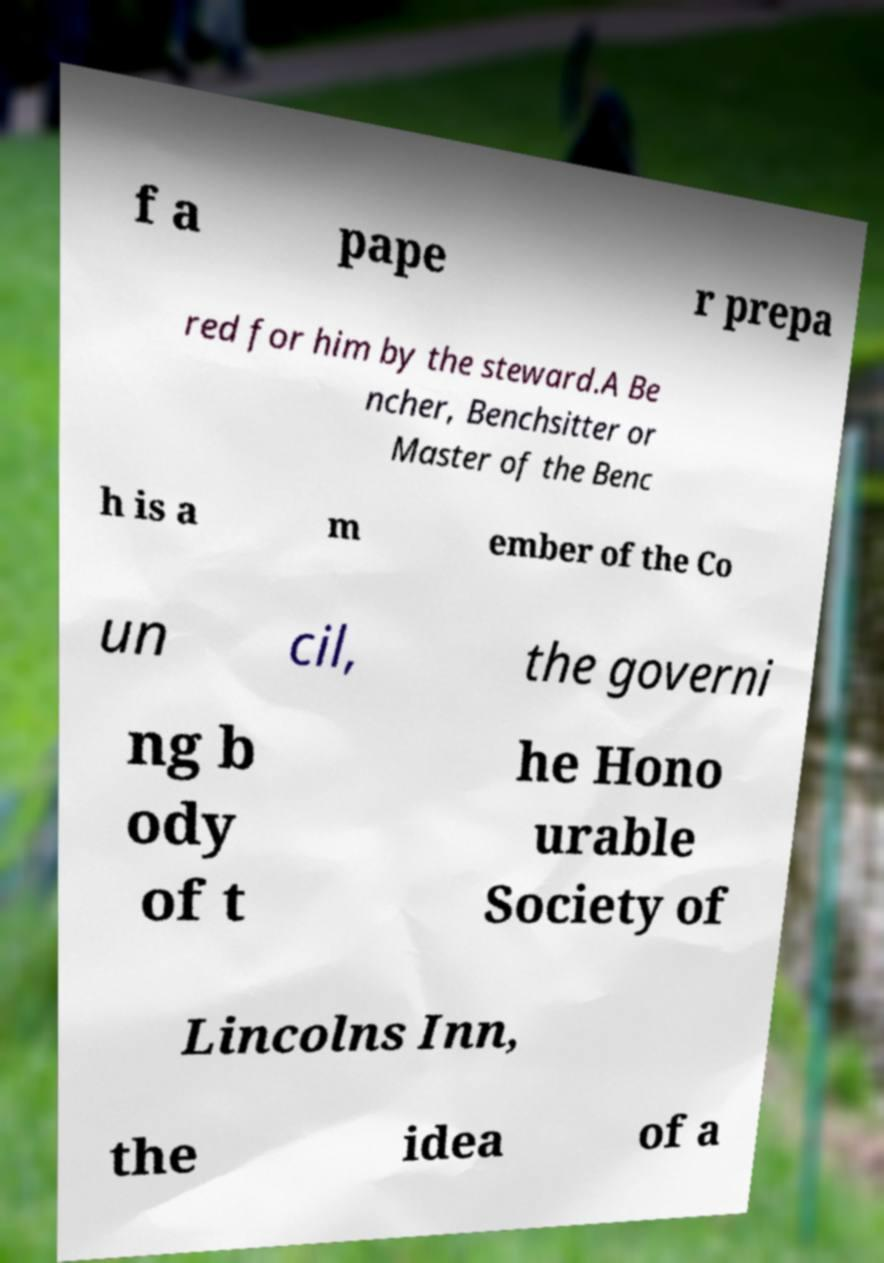Please identify and transcribe the text found in this image. f a pape r prepa red for him by the steward.A Be ncher, Benchsitter or Master of the Benc h is a m ember of the Co un cil, the governi ng b ody of t he Hono urable Society of Lincolns Inn, the idea of a 